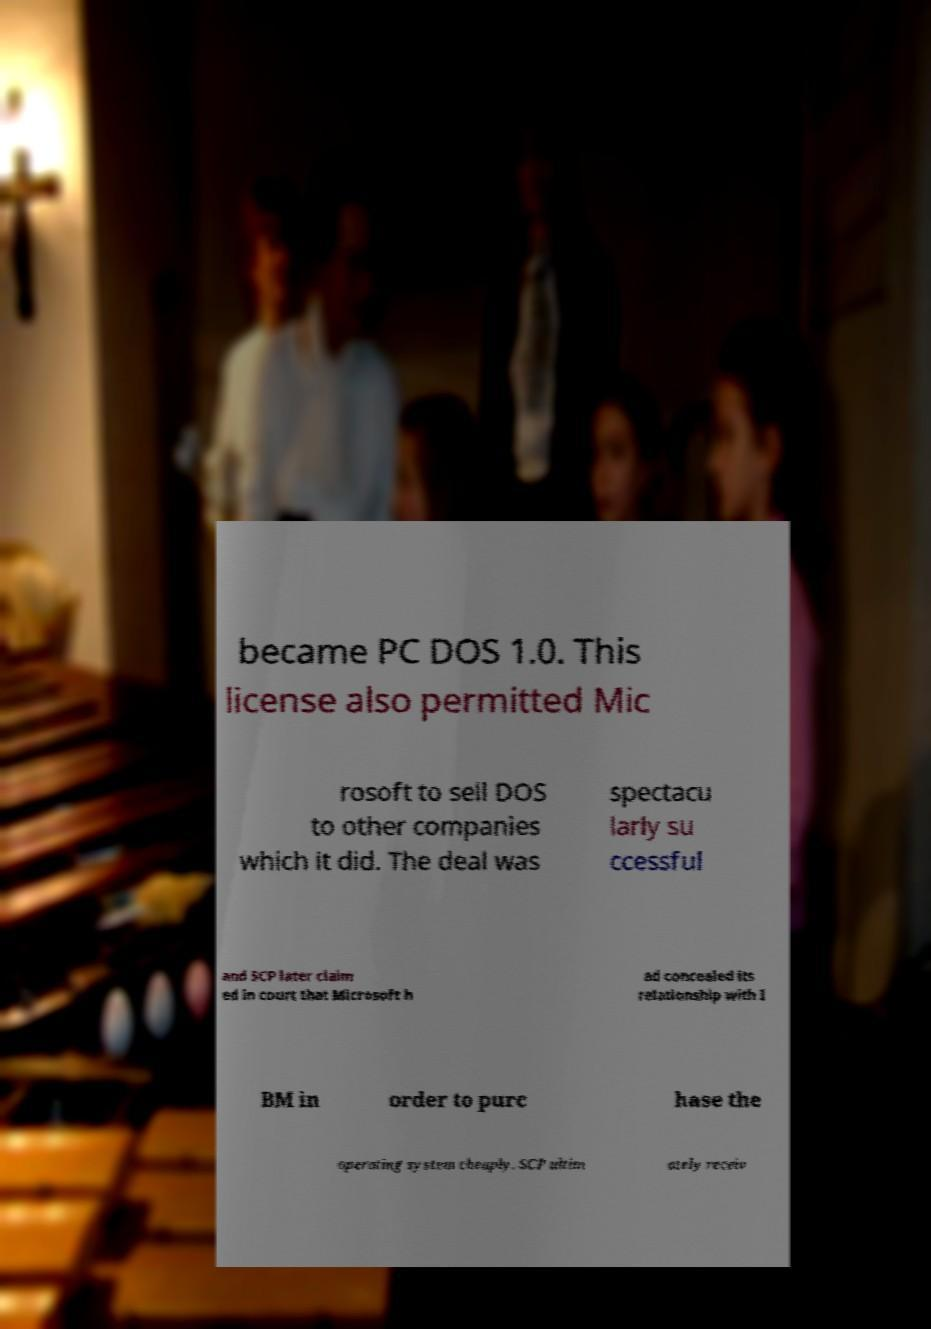Could you extract and type out the text from this image? became PC DOS 1.0. This license also permitted Mic rosoft to sell DOS to other companies which it did. The deal was spectacu larly su ccessful and SCP later claim ed in court that Microsoft h ad concealed its relationship with I BM in order to purc hase the operating system cheaply. SCP ultim ately receiv 